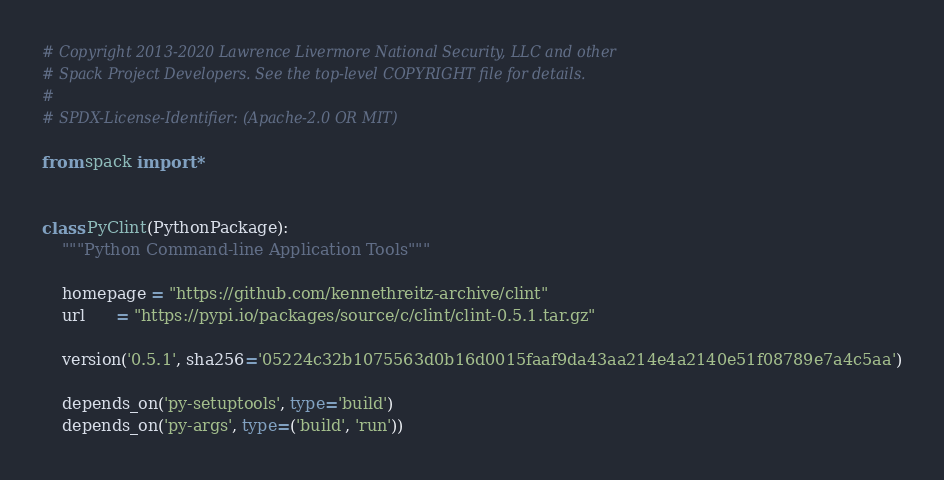Convert code to text. <code><loc_0><loc_0><loc_500><loc_500><_Python_># Copyright 2013-2020 Lawrence Livermore National Security, LLC and other
# Spack Project Developers. See the top-level COPYRIGHT file for details.
#
# SPDX-License-Identifier: (Apache-2.0 OR MIT)

from spack import *


class PyClint(PythonPackage):
    """Python Command-line Application Tools"""

    homepage = "https://github.com/kennethreitz-archive/clint"
    url      = "https://pypi.io/packages/source/c/clint/clint-0.5.1.tar.gz"

    version('0.5.1', sha256='05224c32b1075563d0b16d0015faaf9da43aa214e4a2140e51f08789e7a4c5aa')

    depends_on('py-setuptools', type='build')
    depends_on('py-args', type=('build', 'run'))
</code> 